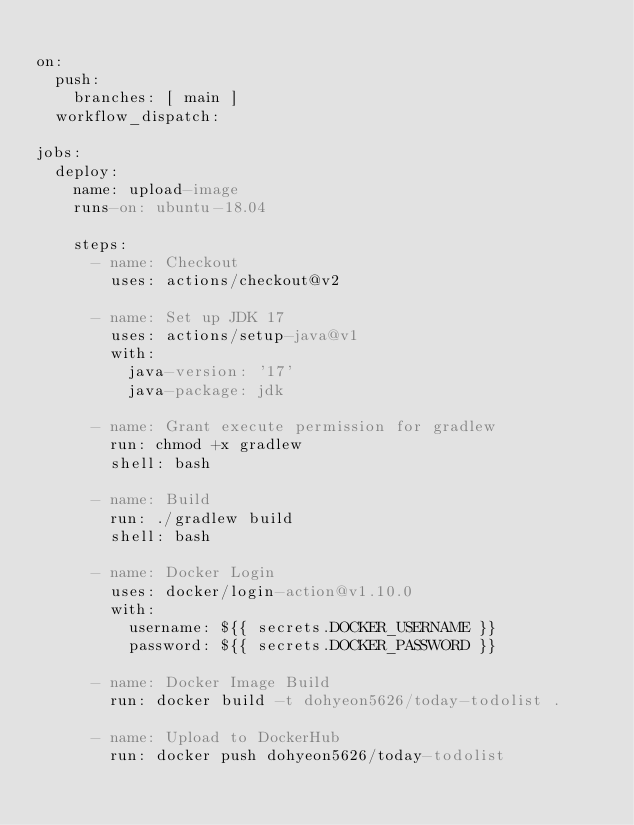<code> <loc_0><loc_0><loc_500><loc_500><_YAML_>
on:
  push:
    branches: [ main ]
  workflow_dispatch:

jobs:
  deploy:
    name: upload-image
    runs-on: ubuntu-18.04

    steps:
      - name: Checkout
        uses: actions/checkout@v2

      - name: Set up JDK 17
        uses: actions/setup-java@v1
        with:
          java-version: '17'
          java-package: jdk

      - name: Grant execute permission for gradlew
        run: chmod +x gradlew
        shell: bash

      - name: Build
        run: ./gradlew build
        shell: bash

      - name: Docker Login
        uses: docker/login-action@v1.10.0
        with:
          username: ${{ secrets.DOCKER_USERNAME }}
          password: ${{ secrets.DOCKER_PASSWORD }}
      
      - name: Docker Image Build
        run: docker build -t dohyeon5626/today-todolist .

      - name: Upload to DockerHub
        run: docker push dohyeon5626/today-todolist
</code> 